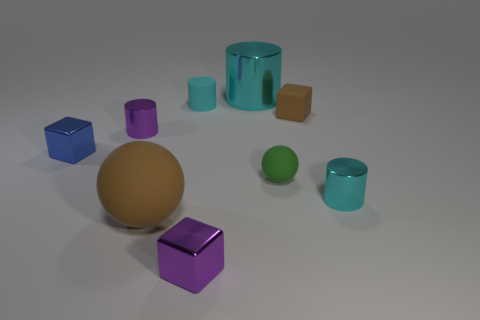Add 1 tiny brown rubber spheres. How many objects exist? 10 Subtract all purple cylinders. How many cylinders are left? 3 Subtract all brown cubes. How many cubes are left? 2 Subtract 2 cubes. How many cubes are left? 1 Add 2 brown things. How many brown things are left? 4 Add 4 blue things. How many blue things exist? 5 Subtract 0 purple spheres. How many objects are left? 9 Subtract all balls. How many objects are left? 7 Subtract all blue spheres. Subtract all blue cylinders. How many spheres are left? 2 Subtract all gray spheres. How many cyan cylinders are left? 3 